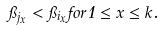<formula> <loc_0><loc_0><loc_500><loc_500>\pi _ { j _ { x } } < \pi _ { i _ { x } } f o r 1 \leq x \leq k .</formula> 